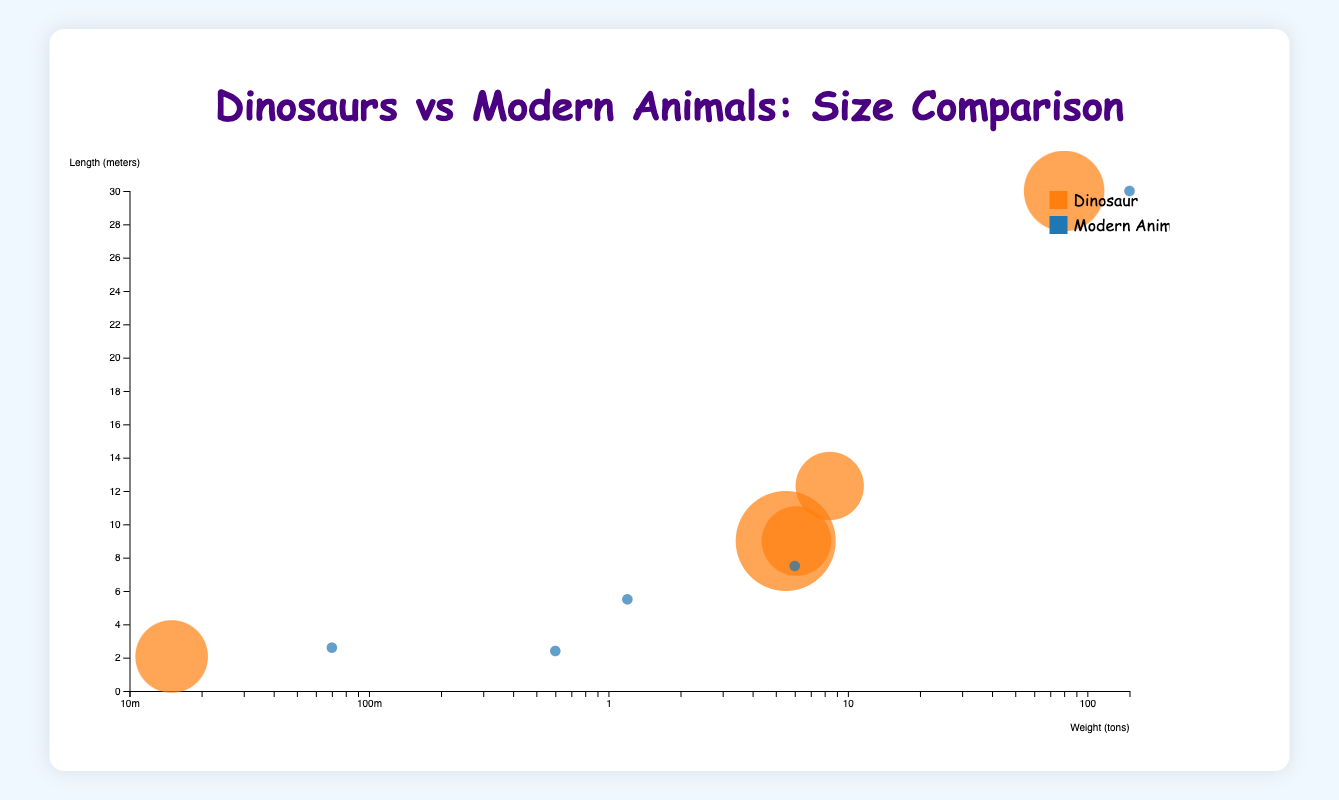What is the title of the chart? The title is usually found at the top, center of the chart. In this case, it says "Dinosaurs vs Modern Animals: Size Comparison".
Answer: Dinosaurs vs Modern Animals: Size Comparison How many types of animals are represented in the chart? The legend indicates different colors for the types ‘Dinosaur’ and ‘Modern Animal’. Counting these, we see there are two types.
Answer: Two How many animal species are plotted in the chart? There should be 10 circles, each representing a different animal species.
Answer: Ten Which animal has the largest circle in the chart? The size of the circle is proportional to the era the animal lived. The Blue Whale, a modern animal, has the largest circle since it represents 0.005 million years ago and is closest to zero.
Answer: Blue Whale Which dinosaur has the highest weight? Look for the dinosaur with the circle farthest to the right along the X-axis that represents weight. Argentinosaurus is at 80 tons, the highest among all dinosaurs.
Answer: Argentinosaurus Which modern animal has the longest length? Look along the Y-axis for the circle positioned the highest among the modern animals. The Blue Whale is positioned at 30 meters.
Answer: Blue Whale How many dinosaurs are heavier than 10 tons? Examine the X-axis to identify the circles representing dinosaurs with weights exceeding 10 tons. Two dinosaurs, Tyrannosaurus Rex and Argentinosaurus, qualify.
Answer: Two Which animal has the smallest size bubble? The smallest bubble corresponds to the earliest era. Velociraptor, living 75 million years ago, has the smallest size bubble.
Answer: Velociraptor Which era has the most species represented in the chart? Look at the key showing the era on the bubbles. The smallest size bubbles indicate dinosaurs, specifically around 65-155 million years ago, representing five dinosaurs.
Answer: Dinosaur Era (65-155 million years ago) Which weighs more: Tyrannosaurus Rex or African Elephant, and by how much? Compare the X-axis positions of Tyrannosaurus Rex (8.4 tons) and African Elephant (6 tons). Subtraction gives the difference of 2.4 tons.
Answer: Tyrannosaurus Rex, 2.4 tons 